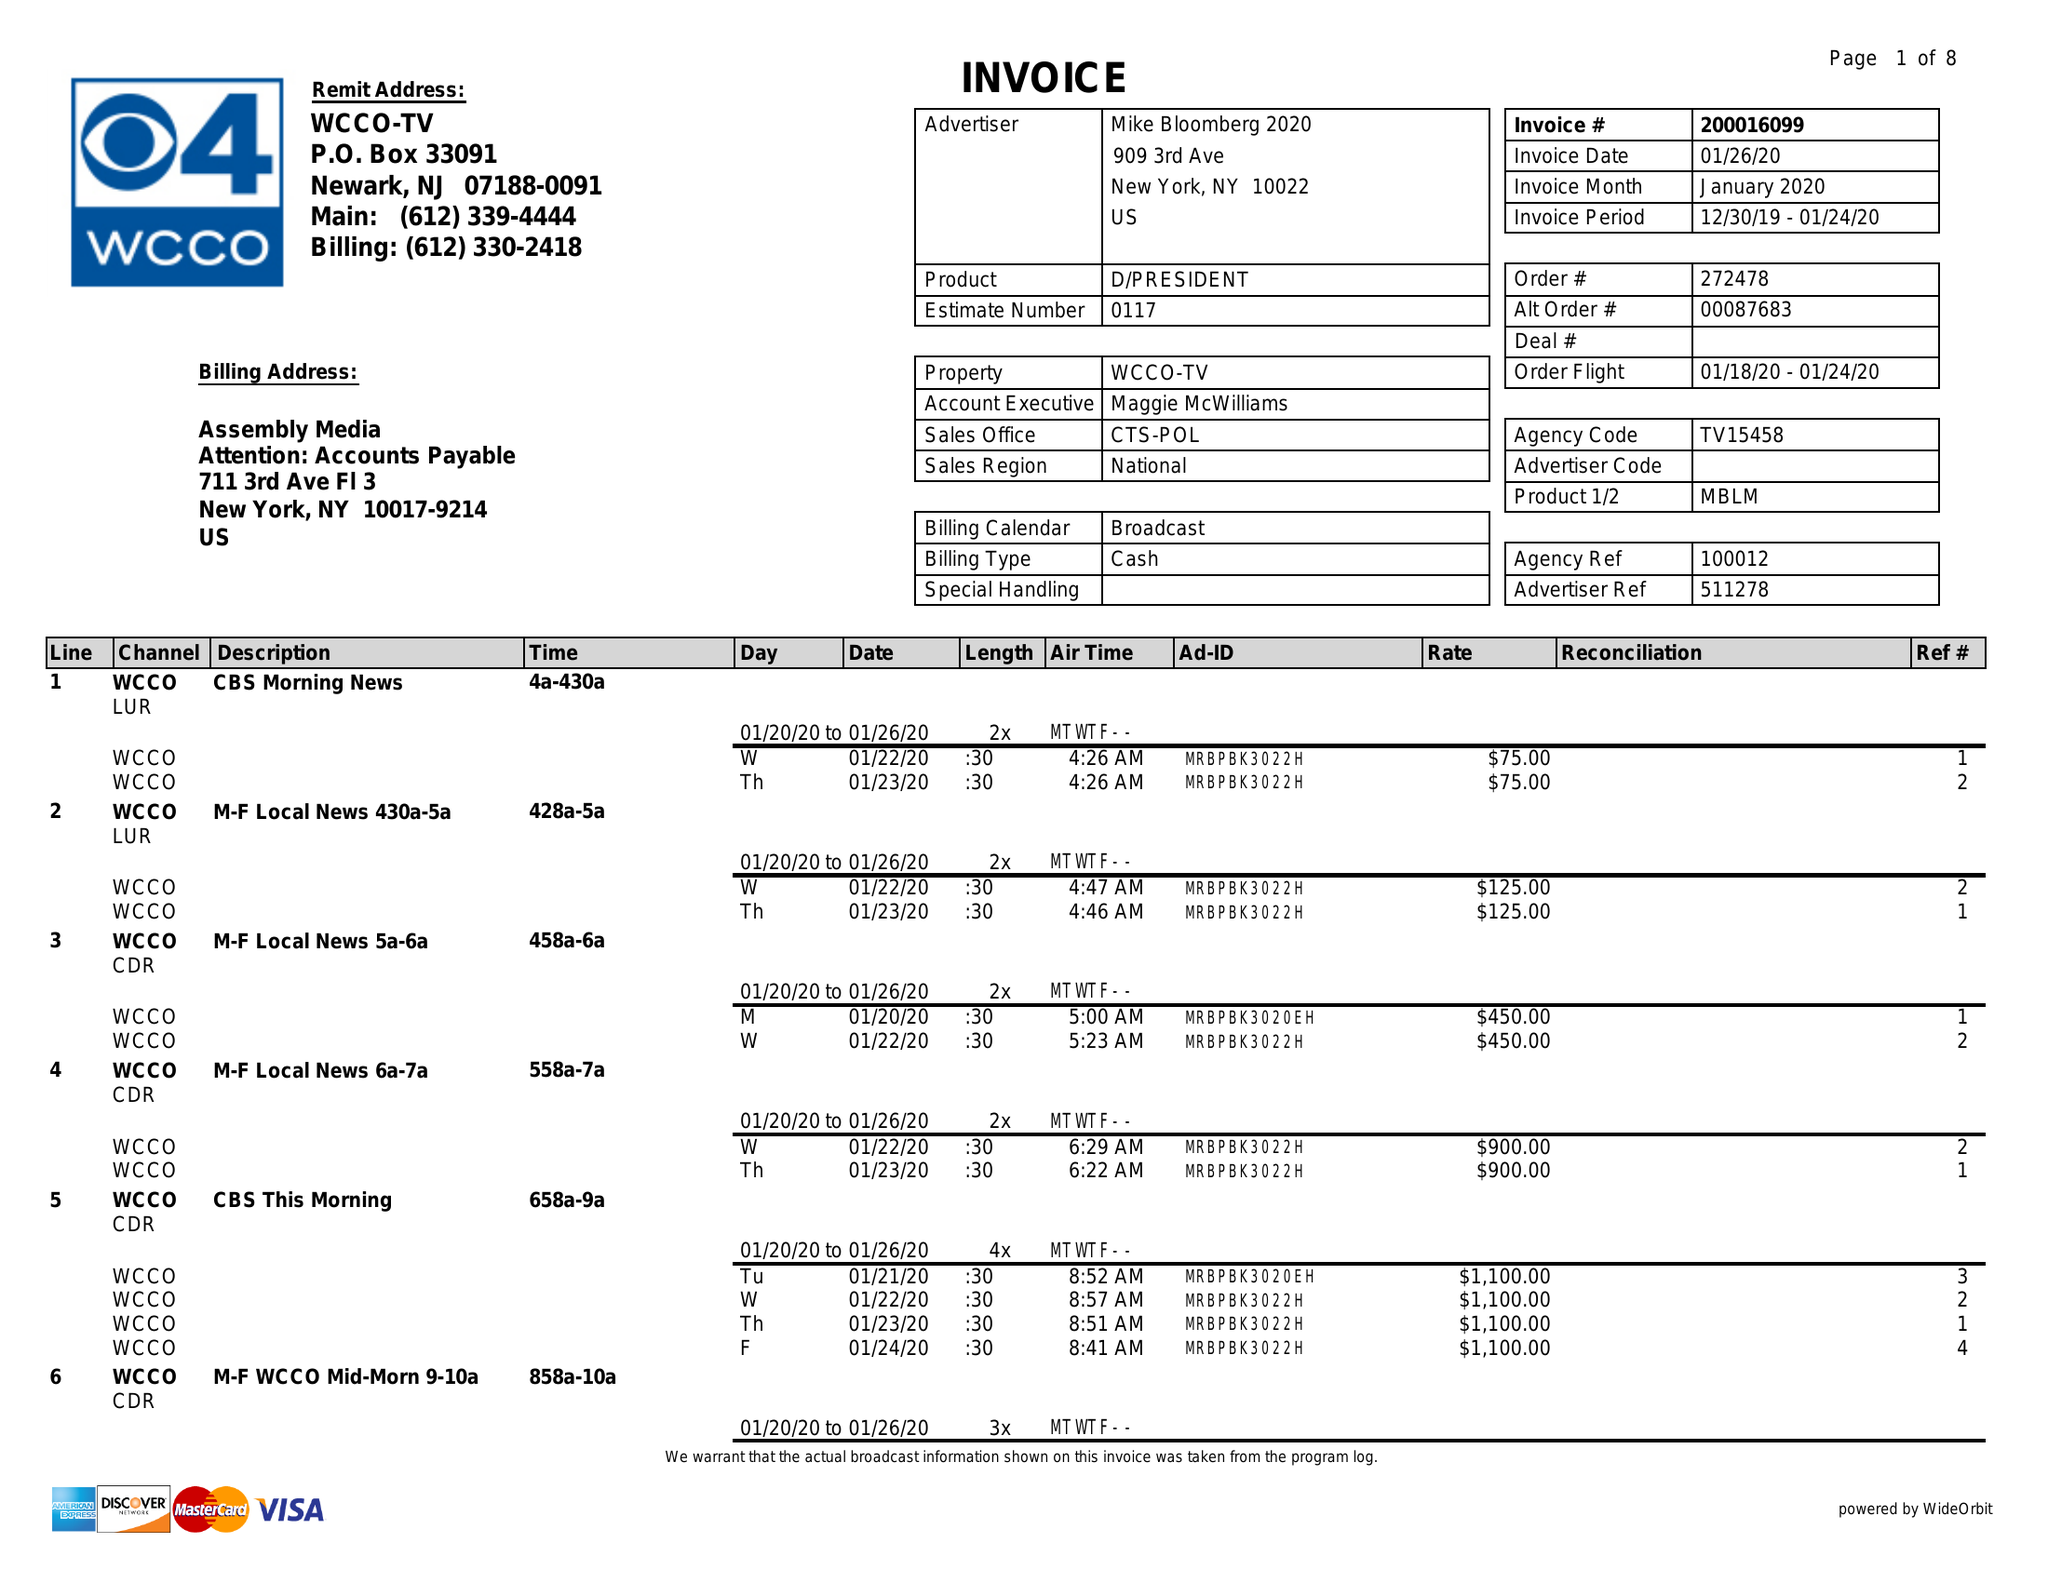What is the value for the gross_amount?
Answer the question using a single word or phrase. 166855.00 